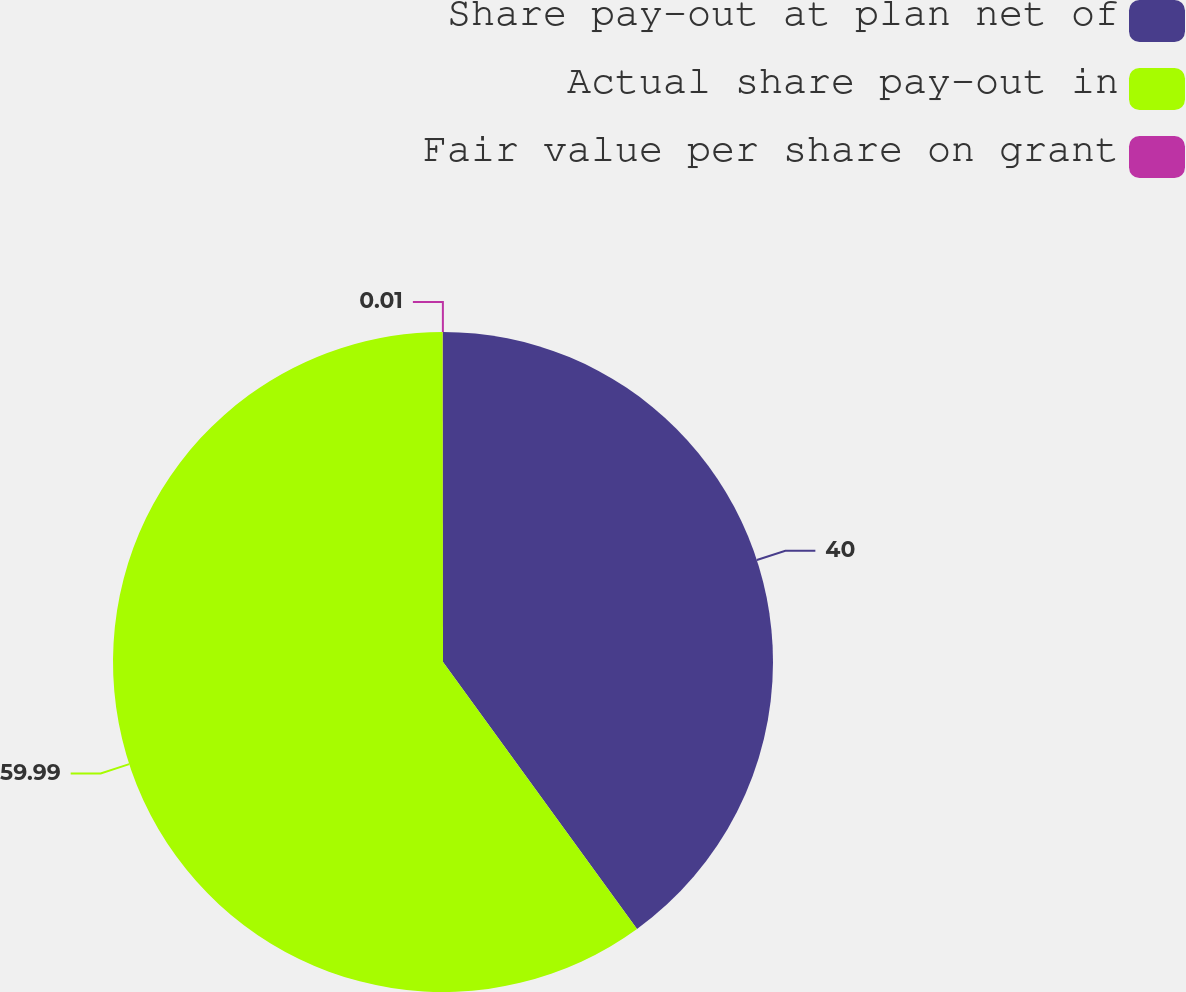Convert chart. <chart><loc_0><loc_0><loc_500><loc_500><pie_chart><fcel>Share pay-out at plan net of<fcel>Actual share pay-out in<fcel>Fair value per share on grant<nl><fcel>40.0%<fcel>60.0%<fcel>0.01%<nl></chart> 